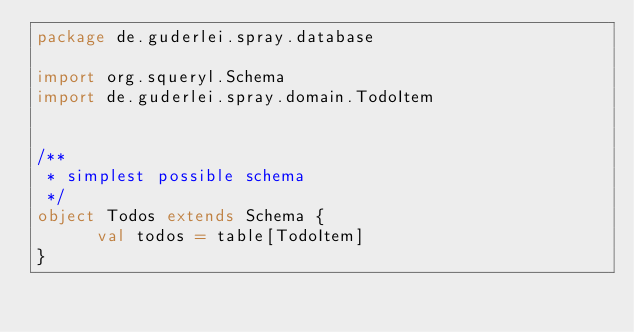Convert code to text. <code><loc_0><loc_0><loc_500><loc_500><_Scala_>package de.guderlei.spray.database

import org.squeryl.Schema
import de.guderlei.spray.domain.TodoItem


/**
 * simplest possible schema
 */
object Todos extends Schema {
      val todos = table[TodoItem]
}
</code> 